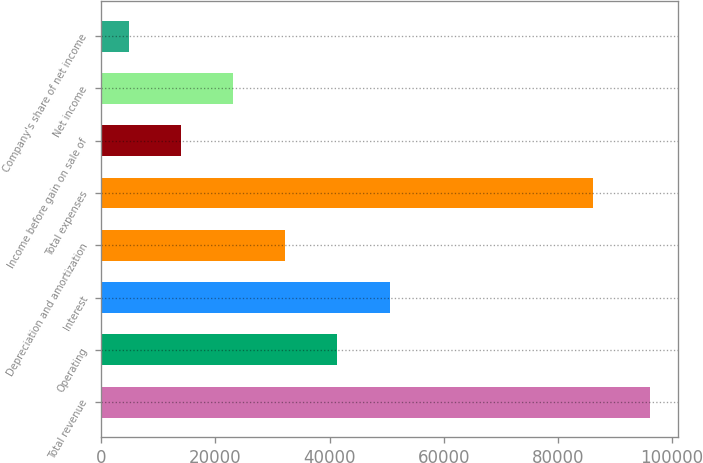<chart> <loc_0><loc_0><loc_500><loc_500><bar_chart><fcel>Total revenue<fcel>Operating<fcel>Interest<fcel>Depreciation and amortization<fcel>Total expenses<fcel>Income before gain on sale of<fcel>Net income<fcel>Company's share of net income<nl><fcel>96189<fcel>41373<fcel>50509<fcel>32237<fcel>86177<fcel>13965<fcel>23101<fcel>4829<nl></chart> 